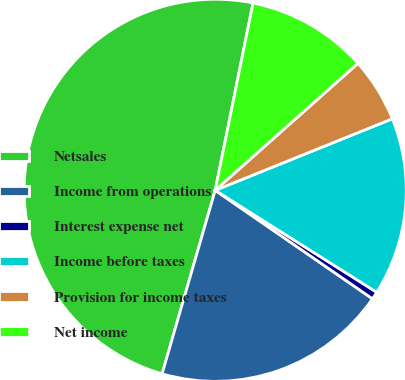Convert chart to OTSL. <chart><loc_0><loc_0><loc_500><loc_500><pie_chart><fcel>Netsales<fcel>Income from operations<fcel>Interest expense net<fcel>Income before taxes<fcel>Provision for income taxes<fcel>Net income<nl><fcel>48.69%<fcel>19.87%<fcel>0.65%<fcel>15.07%<fcel>5.46%<fcel>10.26%<nl></chart> 